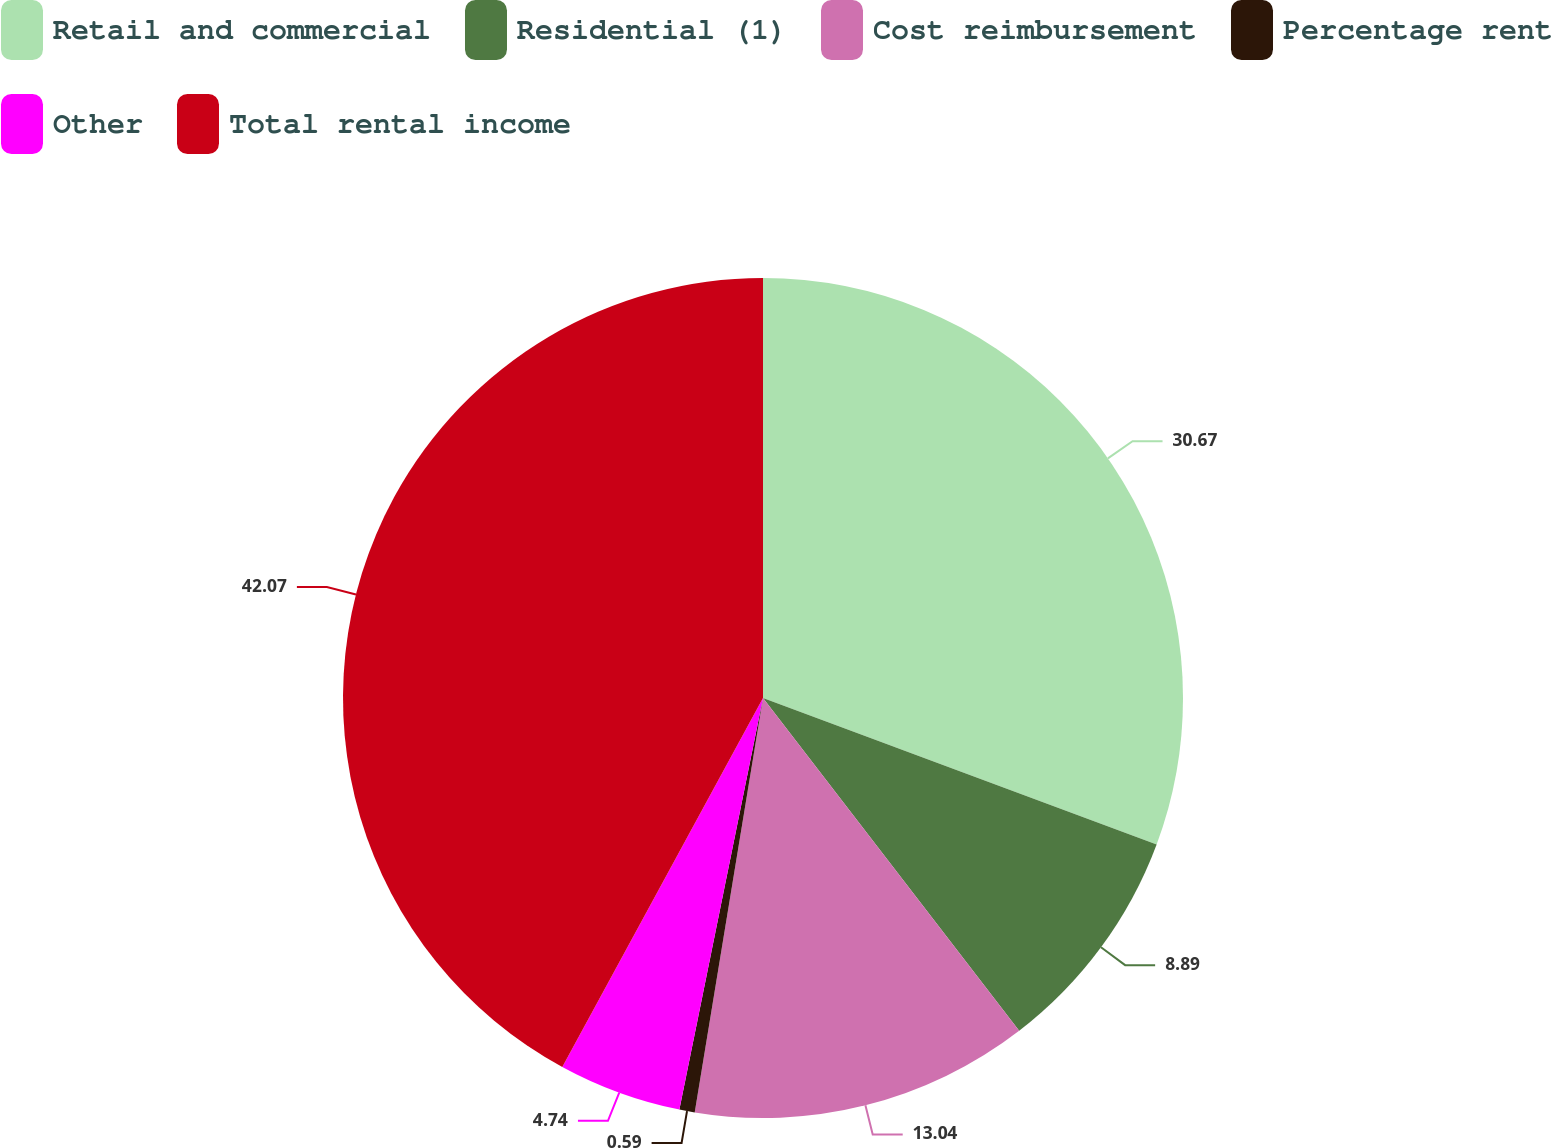<chart> <loc_0><loc_0><loc_500><loc_500><pie_chart><fcel>Retail and commercial<fcel>Residential (1)<fcel>Cost reimbursement<fcel>Percentage rent<fcel>Other<fcel>Total rental income<nl><fcel>30.67%<fcel>8.89%<fcel>13.04%<fcel>0.59%<fcel>4.74%<fcel>42.07%<nl></chart> 